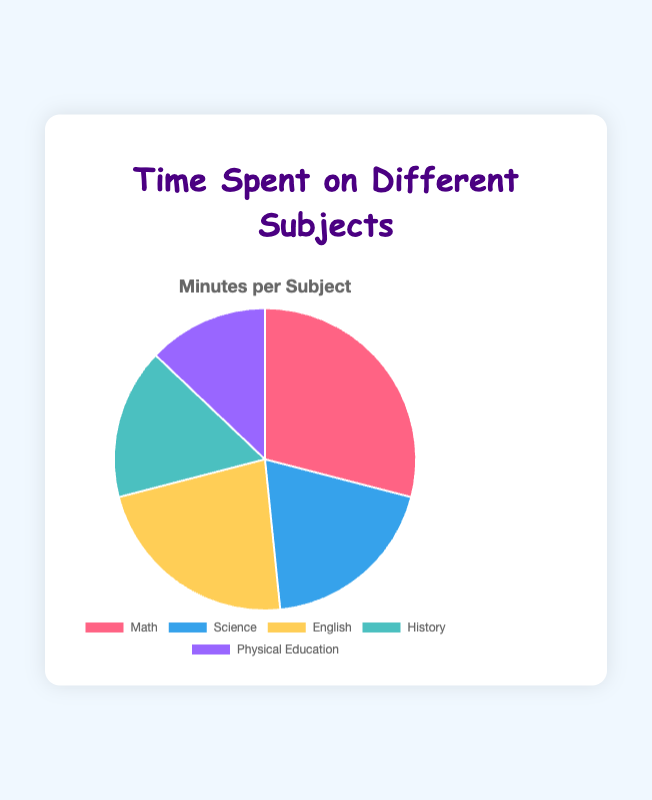Which subject has the most time spent on it? Looking at the pie chart, the largest segment represents Math with 90 minutes.
Answer: Math Which subject has the second highest time spent on it? The second largest segment on the pie chart is Science, with 60 minutes.
Answer: Science How much more time is spent on Math compared to Physical Education? Subtract the time spent on Physical Education from the time spent on Math: 90 - 40 = 50 minutes.
Answer: 50 minutes What is the total time spent on English and History? Add the time spent on English and History: 70 + 50 = 120 minutes.
Answer: 120 minutes What is the sum of the time spent on non-math subjects? Sum the time spent on Science, English, History, and Physical Education: 60 + 70 + 50 + 40 = 220 minutes.
Answer: 220 minutes How much less time is spent on Physical Education compared to Science? Subtract the time spent on Physical Education from the time spent on Science: 60 - 40 = 20 minutes.
Answer: 20 minutes Which subjects have less than 1 hour of time spent? Subjects with less than 60 minutes are History (50 minutes) and Physical Education (40 minutes).
Answer: History and Physical Education What is the average time spent per subject? Add the times for all subjects and divide by the number of subjects: (90 + 60 + 70 + 50 + 40) / 5 = 62 minutes.
Answer: 62 minutes How does the time spent on English compare to the time spent on Science? The time spent on English (70 minutes) is 10 minutes more than the time spent on Science (60 minutes).
Answer: English has 10 minutes more 